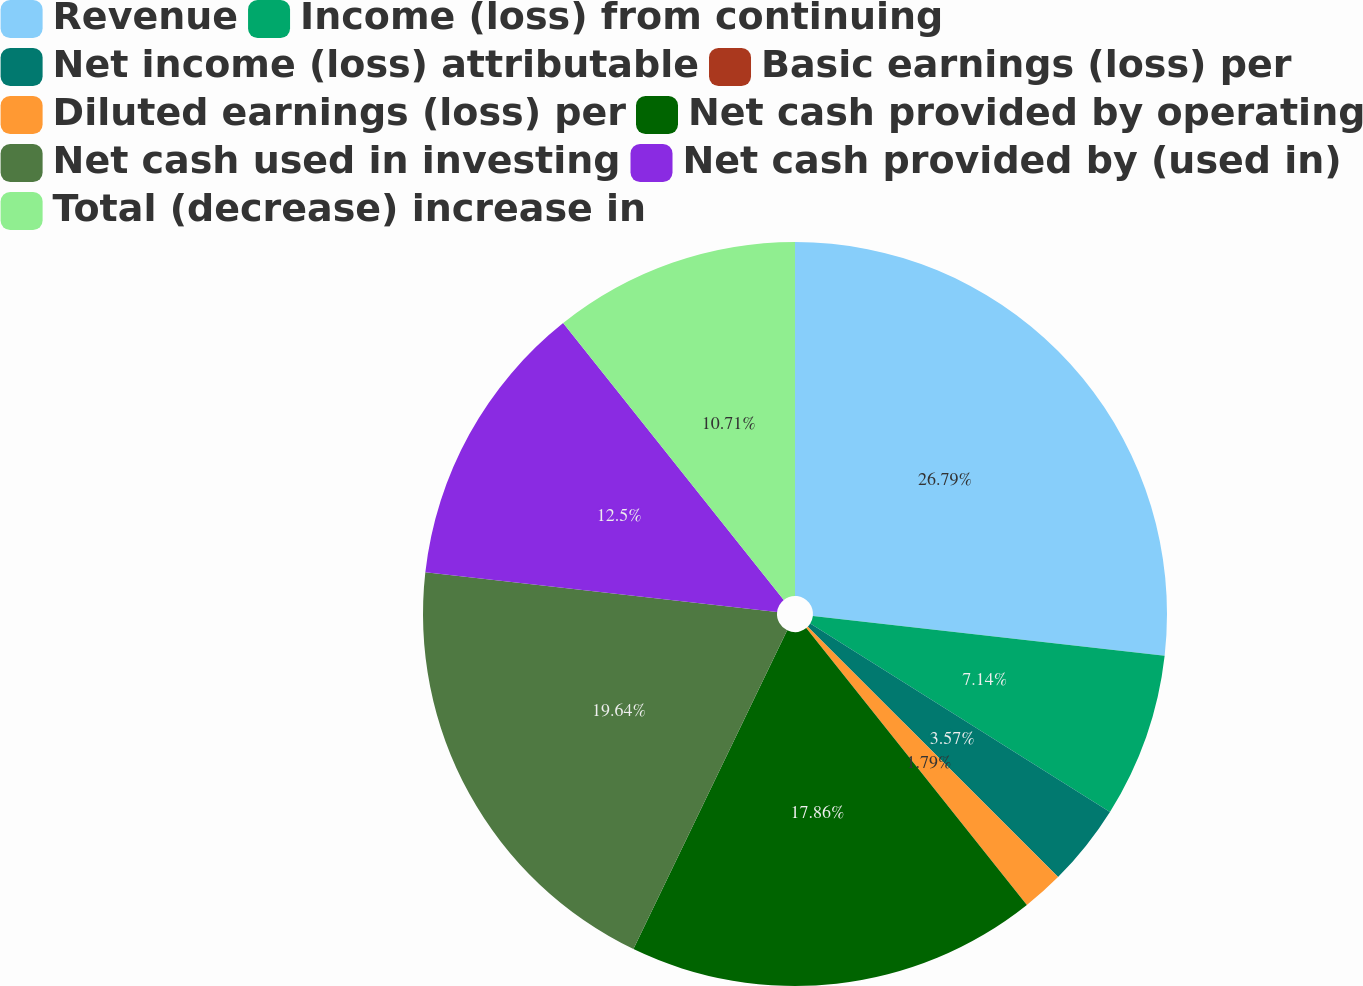Convert chart to OTSL. <chart><loc_0><loc_0><loc_500><loc_500><pie_chart><fcel>Revenue<fcel>Income (loss) from continuing<fcel>Net income (loss) attributable<fcel>Basic earnings (loss) per<fcel>Diluted earnings (loss) per<fcel>Net cash provided by operating<fcel>Net cash used in investing<fcel>Net cash provided by (used in)<fcel>Total (decrease) increase in<nl><fcel>26.79%<fcel>7.14%<fcel>3.57%<fcel>0.0%<fcel>1.79%<fcel>17.86%<fcel>19.64%<fcel>12.5%<fcel>10.71%<nl></chart> 